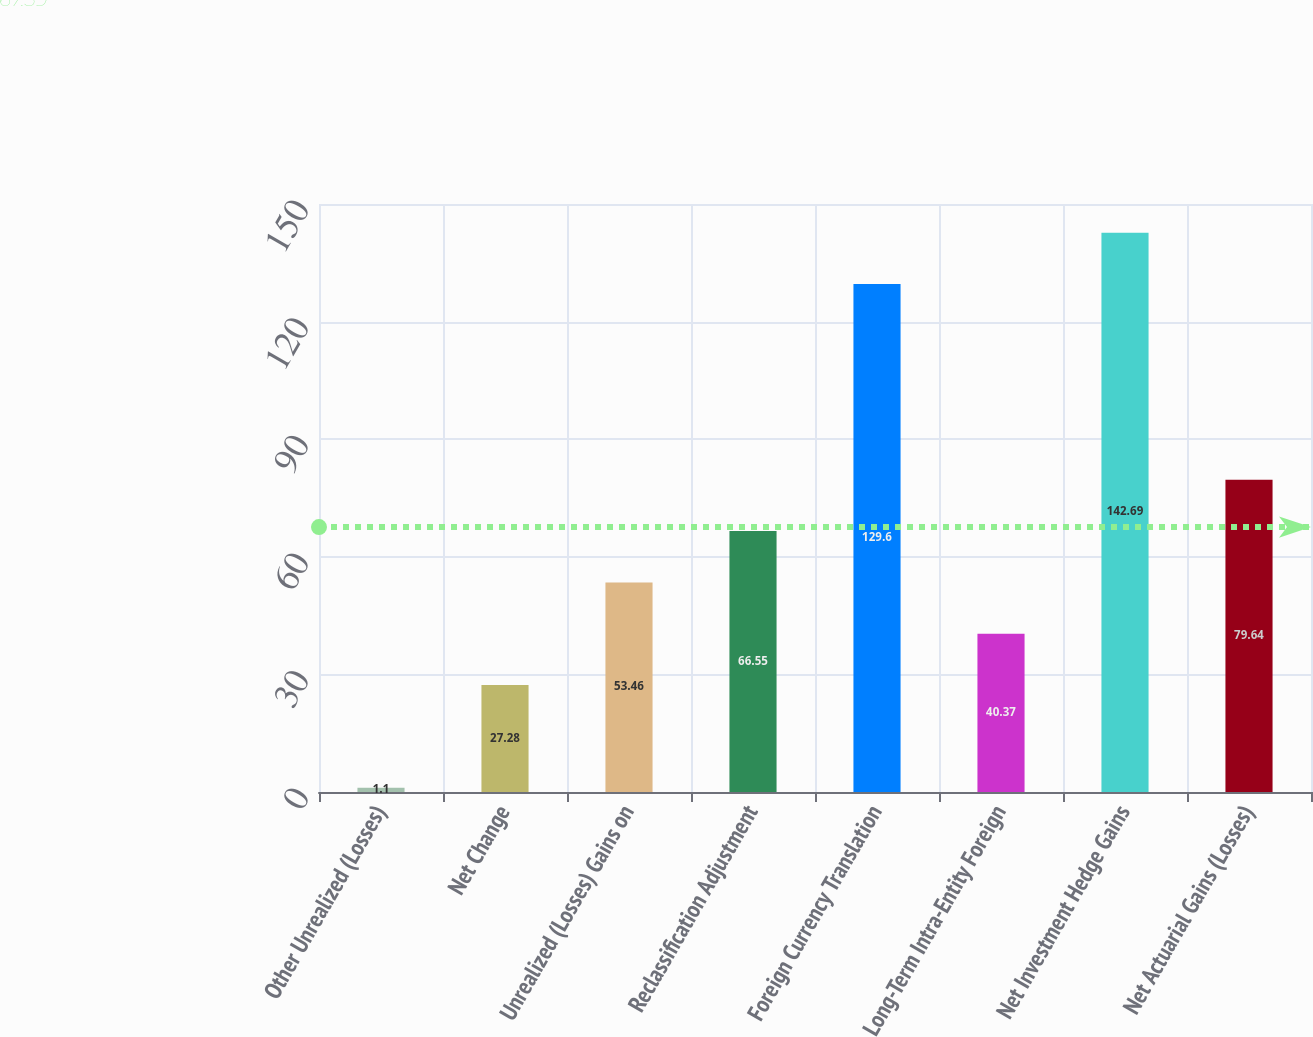Convert chart. <chart><loc_0><loc_0><loc_500><loc_500><bar_chart><fcel>Other Unrealized (Losses)<fcel>Net Change<fcel>Unrealized (Losses) Gains on<fcel>Reclassification Adjustment<fcel>Foreign Currency Translation<fcel>Long-Term Intra-Entity Foreign<fcel>Net Investment Hedge Gains<fcel>Net Actuarial Gains (Losses)<nl><fcel>1.1<fcel>27.28<fcel>53.46<fcel>66.55<fcel>129.6<fcel>40.37<fcel>142.69<fcel>79.64<nl></chart> 